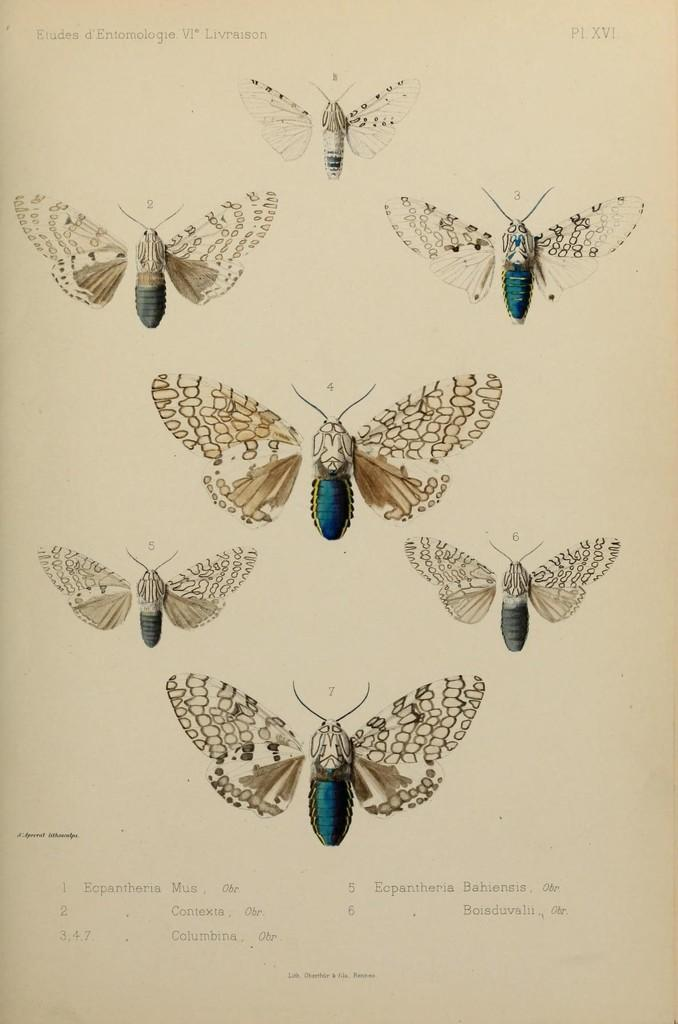What is the main subject of the image? There is a photo in the image. What can be seen in the photo? There are butterflies in the photo. What type of noise can be heard coming from the butterflies in the image? Butterflies do not make noise, so there is no noise coming from them in the image. 